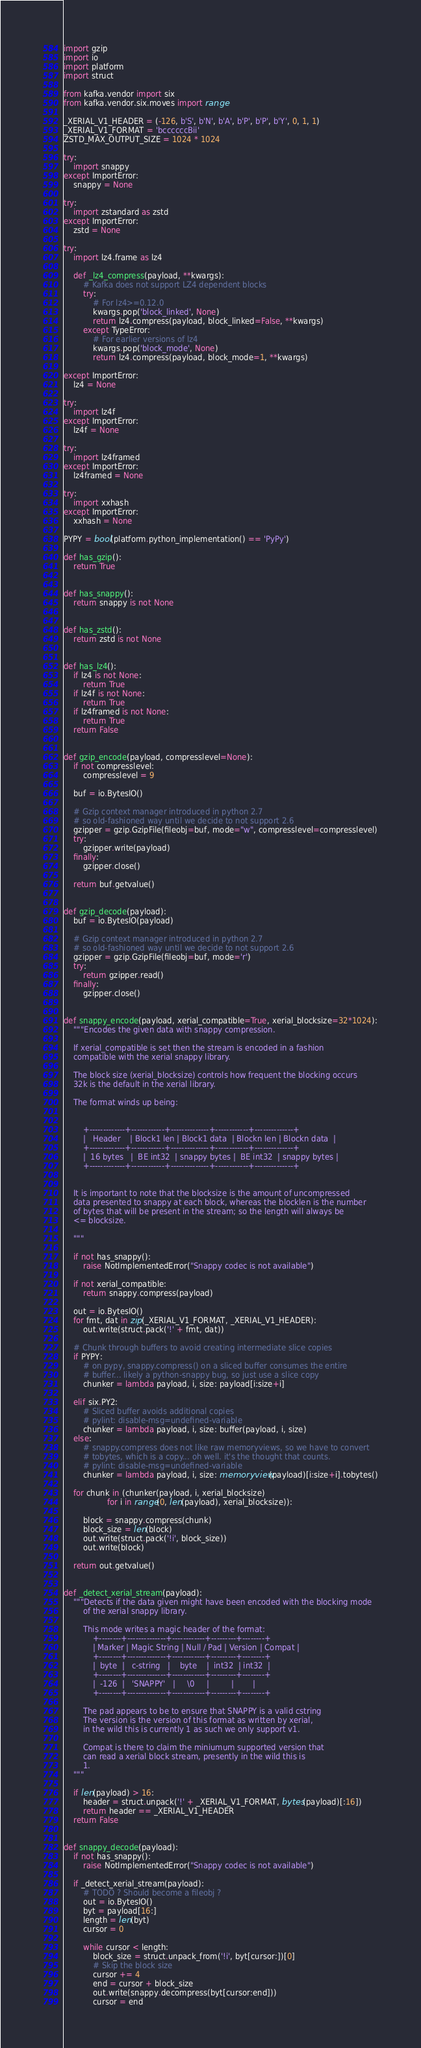Convert code to text. <code><loc_0><loc_0><loc_500><loc_500><_Python_>
import gzip
import io
import platform
import struct

from kafka.vendor import six
from kafka.vendor.six.moves import range

_XERIAL_V1_HEADER = (-126, b'S', b'N', b'A', b'P', b'P', b'Y', 0, 1, 1)
_XERIAL_V1_FORMAT = 'bccccccBii'
ZSTD_MAX_OUTPUT_SIZE = 1024 * 1024

try:
    import snappy
except ImportError:
    snappy = None

try:
    import zstandard as zstd
except ImportError:
    zstd = None

try:
    import lz4.frame as lz4

    def _lz4_compress(payload, **kwargs):
        # Kafka does not support LZ4 dependent blocks
        try:
            # For lz4>=0.12.0
            kwargs.pop('block_linked', None)
            return lz4.compress(payload, block_linked=False, **kwargs)
        except TypeError:
            # For earlier versions of lz4
            kwargs.pop('block_mode', None)
            return lz4.compress(payload, block_mode=1, **kwargs)

except ImportError:
    lz4 = None

try:
    import lz4f
except ImportError:
    lz4f = None

try:
    import lz4framed
except ImportError:
    lz4framed = None

try:
    import xxhash
except ImportError:
    xxhash = None

PYPY = bool(platform.python_implementation() == 'PyPy')

def has_gzip():
    return True


def has_snappy():
    return snappy is not None


def has_zstd():
    return zstd is not None


def has_lz4():
    if lz4 is not None:
        return True
    if lz4f is not None:
        return True
    if lz4framed is not None:
        return True
    return False


def gzip_encode(payload, compresslevel=None):
    if not compresslevel:
        compresslevel = 9

    buf = io.BytesIO()

    # Gzip context manager introduced in python 2.7
    # so old-fashioned way until we decide to not support 2.6
    gzipper = gzip.GzipFile(fileobj=buf, mode="w", compresslevel=compresslevel)
    try:
        gzipper.write(payload)
    finally:
        gzipper.close()

    return buf.getvalue()


def gzip_decode(payload):
    buf = io.BytesIO(payload)

    # Gzip context manager introduced in python 2.7
    # so old-fashioned way until we decide to not support 2.6
    gzipper = gzip.GzipFile(fileobj=buf, mode='r')
    try:
        return gzipper.read()
    finally:
        gzipper.close()


def snappy_encode(payload, xerial_compatible=True, xerial_blocksize=32*1024):
    """Encodes the given data with snappy compression.

    If xerial_compatible is set then the stream is encoded in a fashion
    compatible with the xerial snappy library.

    The block size (xerial_blocksize) controls how frequent the blocking occurs
    32k is the default in the xerial library.

    The format winds up being:


        +-------------+------------+--------------+------------+--------------+
        |   Header    | Block1 len | Block1 data  | Blockn len | Blockn data  |
        +-------------+------------+--------------+------------+--------------+
        |  16 bytes   |  BE int32  | snappy bytes |  BE int32  | snappy bytes |
        +-------------+------------+--------------+------------+--------------+


    It is important to note that the blocksize is the amount of uncompressed
    data presented to snappy at each block, whereas the blocklen is the number
    of bytes that will be present in the stream; so the length will always be
    <= blocksize.

    """

    if not has_snappy():
        raise NotImplementedError("Snappy codec is not available")

    if not xerial_compatible:
        return snappy.compress(payload)

    out = io.BytesIO()
    for fmt, dat in zip(_XERIAL_V1_FORMAT, _XERIAL_V1_HEADER):
        out.write(struct.pack('!' + fmt, dat))

    # Chunk through buffers to avoid creating intermediate slice copies
    if PYPY:
        # on pypy, snappy.compress() on a sliced buffer consumes the entire
        # buffer... likely a python-snappy bug, so just use a slice copy
        chunker = lambda payload, i, size: payload[i:size+i]

    elif six.PY2:
        # Sliced buffer avoids additional copies
        # pylint: disable-msg=undefined-variable
        chunker = lambda payload, i, size: buffer(payload, i, size)
    else:
        # snappy.compress does not like raw memoryviews, so we have to convert
        # tobytes, which is a copy... oh well. it's the thought that counts.
        # pylint: disable-msg=undefined-variable
        chunker = lambda payload, i, size: memoryview(payload)[i:size+i].tobytes()

    for chunk in (chunker(payload, i, xerial_blocksize)
                  for i in range(0, len(payload), xerial_blocksize)):

        block = snappy.compress(chunk)
        block_size = len(block)
        out.write(struct.pack('!i', block_size))
        out.write(block)

    return out.getvalue()


def _detect_xerial_stream(payload):
    """Detects if the data given might have been encoded with the blocking mode
        of the xerial snappy library.

        This mode writes a magic header of the format:
            +--------+--------------+------------+---------+--------+
            | Marker | Magic String | Null / Pad | Version | Compat |
            +--------+--------------+------------+---------+--------+
            |  byte  |   c-string   |    byte    |  int32  | int32  |
            +--------+--------------+------------+---------+--------+
            |  -126  |   'SNAPPY'   |     \0     |         |        |
            +--------+--------------+------------+---------+--------+

        The pad appears to be to ensure that SNAPPY is a valid cstring
        The version is the version of this format as written by xerial,
        in the wild this is currently 1 as such we only support v1.

        Compat is there to claim the miniumum supported version that
        can read a xerial block stream, presently in the wild this is
        1.
    """

    if len(payload) > 16:
        header = struct.unpack('!' + _XERIAL_V1_FORMAT, bytes(payload)[:16])
        return header == _XERIAL_V1_HEADER
    return False


def snappy_decode(payload):
    if not has_snappy():
        raise NotImplementedError("Snappy codec is not available")

    if _detect_xerial_stream(payload):
        # TODO ? Should become a fileobj ?
        out = io.BytesIO()
        byt = payload[16:]
        length = len(byt)
        cursor = 0

        while cursor < length:
            block_size = struct.unpack_from('!i', byt[cursor:])[0]
            # Skip the block size
            cursor += 4
            end = cursor + block_size
            out.write(snappy.decompress(byt[cursor:end]))
            cursor = end
</code> 